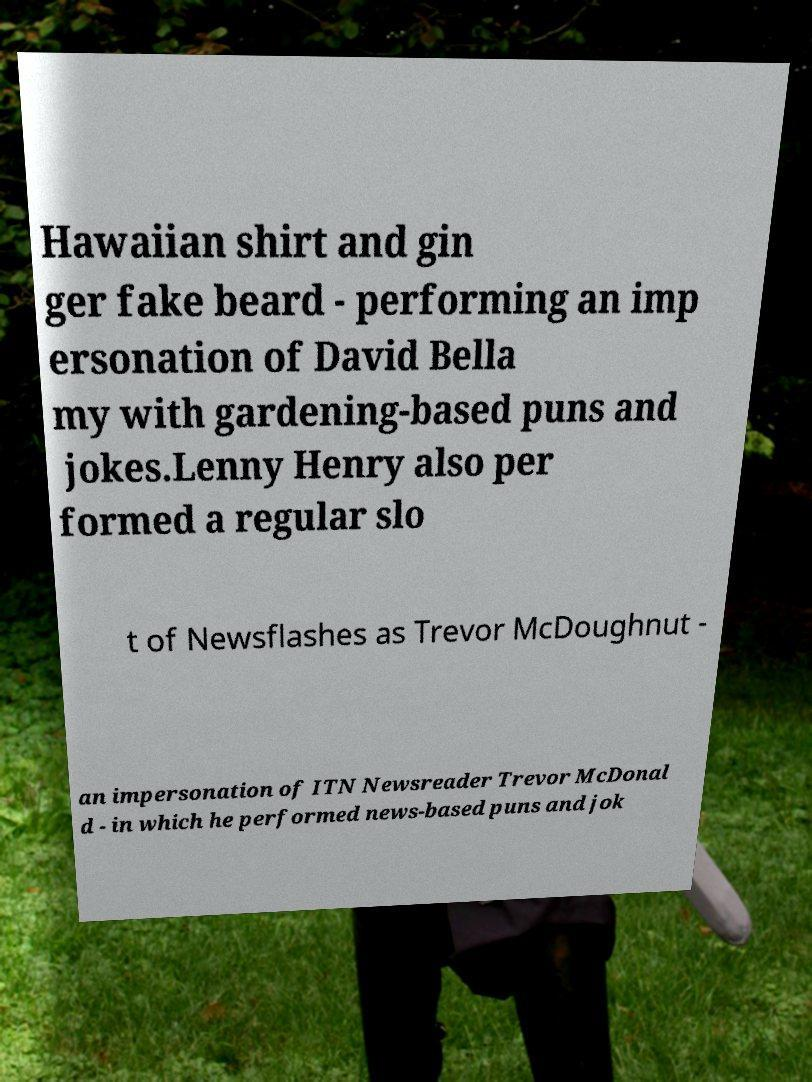Please identify and transcribe the text found in this image. Hawaiian shirt and gin ger fake beard - performing an imp ersonation of David Bella my with gardening-based puns and jokes.Lenny Henry also per formed a regular slo t of Newsflashes as Trevor McDoughnut - an impersonation of ITN Newsreader Trevor McDonal d - in which he performed news-based puns and jok 